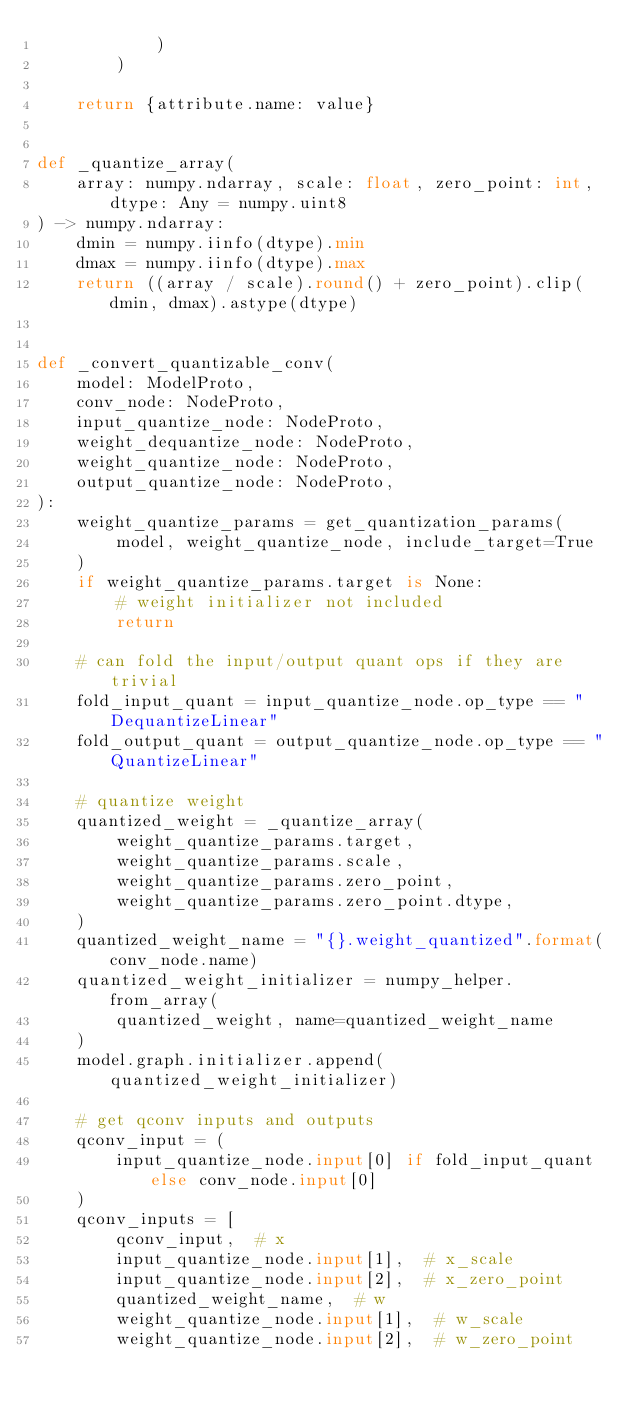Convert code to text. <code><loc_0><loc_0><loc_500><loc_500><_Python_>            )
        )

    return {attribute.name: value}


def _quantize_array(
    array: numpy.ndarray, scale: float, zero_point: int, dtype: Any = numpy.uint8
) -> numpy.ndarray:
    dmin = numpy.iinfo(dtype).min
    dmax = numpy.iinfo(dtype).max
    return ((array / scale).round() + zero_point).clip(dmin, dmax).astype(dtype)


def _convert_quantizable_conv(
    model: ModelProto,
    conv_node: NodeProto,
    input_quantize_node: NodeProto,
    weight_dequantize_node: NodeProto,
    weight_quantize_node: NodeProto,
    output_quantize_node: NodeProto,
):
    weight_quantize_params = get_quantization_params(
        model, weight_quantize_node, include_target=True
    )
    if weight_quantize_params.target is None:
        # weight initializer not included
        return

    # can fold the input/output quant ops if they are trivial
    fold_input_quant = input_quantize_node.op_type == "DequantizeLinear"
    fold_output_quant = output_quantize_node.op_type == "QuantizeLinear"

    # quantize weight
    quantized_weight = _quantize_array(
        weight_quantize_params.target,
        weight_quantize_params.scale,
        weight_quantize_params.zero_point,
        weight_quantize_params.zero_point.dtype,
    )
    quantized_weight_name = "{}.weight_quantized".format(conv_node.name)
    quantized_weight_initializer = numpy_helper.from_array(
        quantized_weight, name=quantized_weight_name
    )
    model.graph.initializer.append(quantized_weight_initializer)

    # get qconv inputs and outputs
    qconv_input = (
        input_quantize_node.input[0] if fold_input_quant else conv_node.input[0]
    )
    qconv_inputs = [
        qconv_input,  # x
        input_quantize_node.input[1],  # x_scale
        input_quantize_node.input[2],  # x_zero_point
        quantized_weight_name,  # w
        weight_quantize_node.input[1],  # w_scale
        weight_quantize_node.input[2],  # w_zero_point</code> 